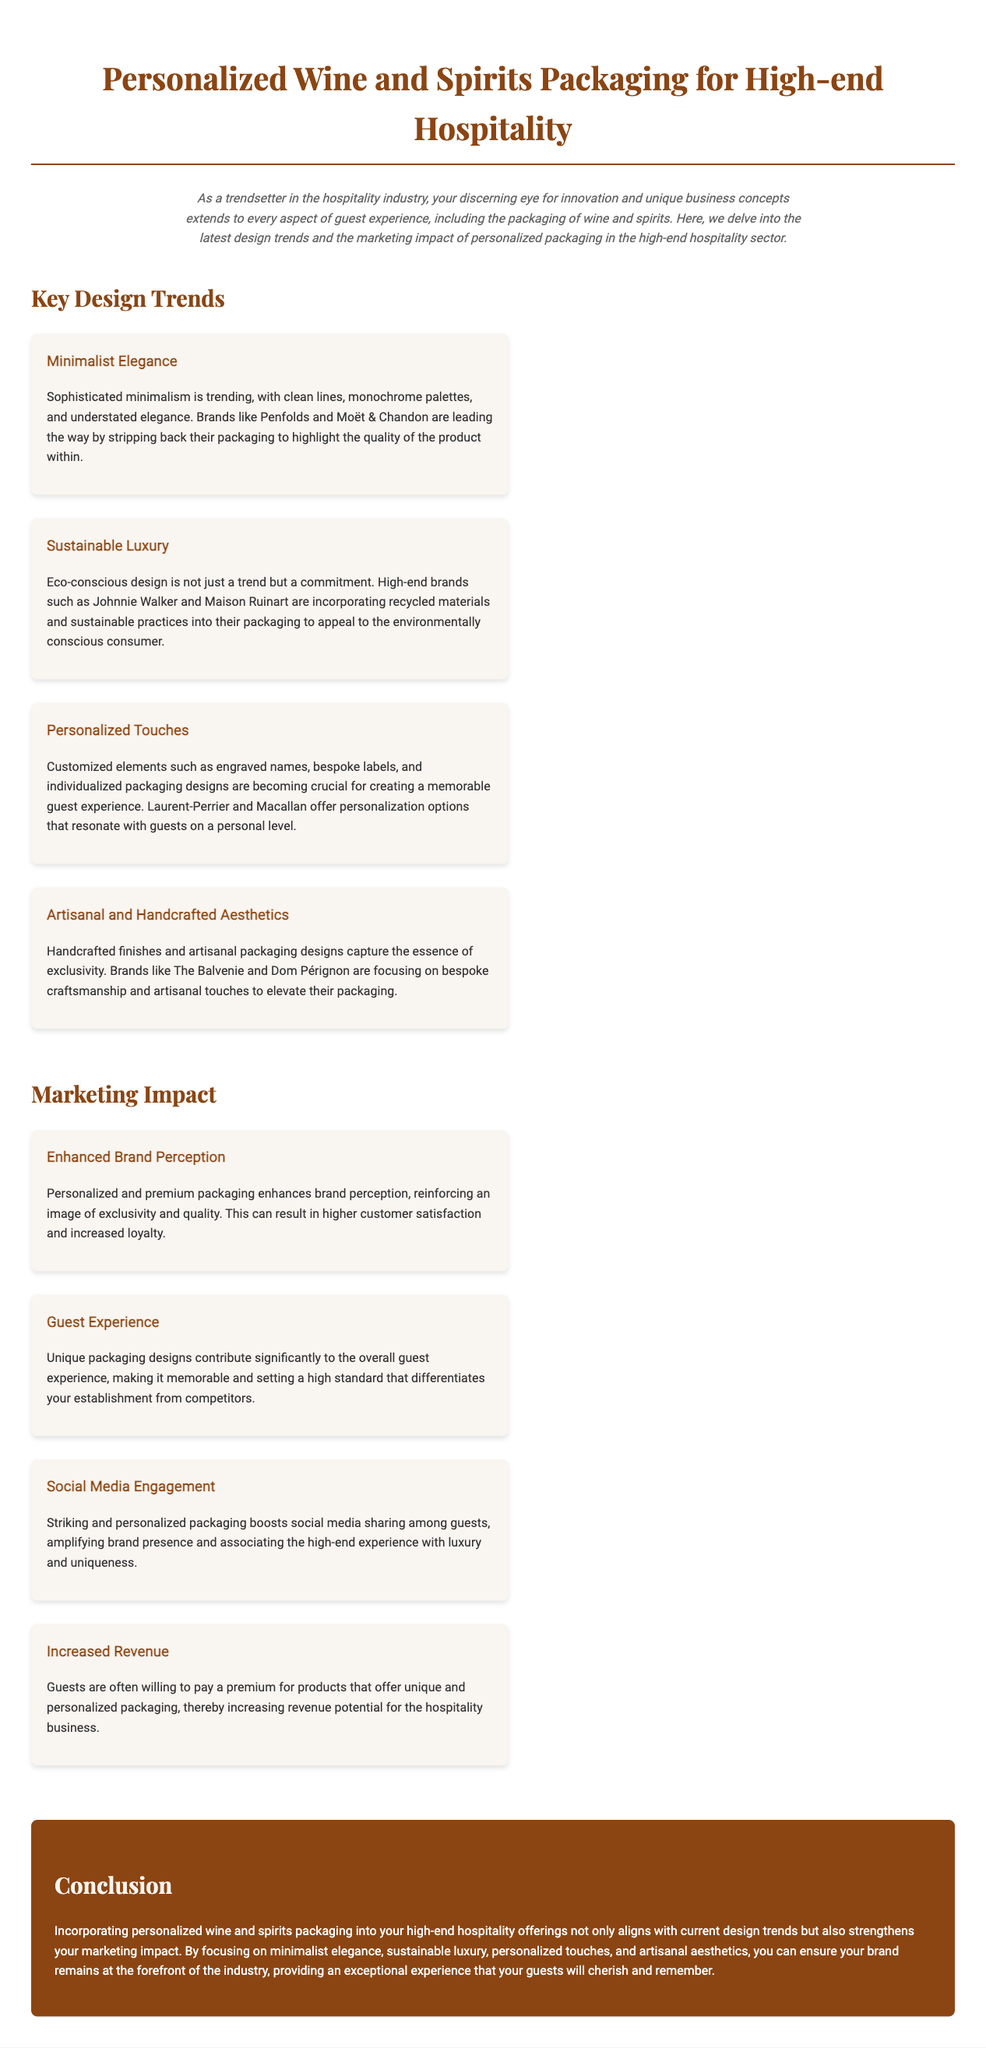What is the main topic of the document? The document discusses personalized wine and spirits packaging specifically for high-end hospitality settings.
Answer: Personalized Wine and Spirits Packaging Which brands are mentioned for minimalist elegance? The document specifically names Penfolds and Moët & Chandon as leading brands in minimalist elegance.
Answer: Penfolds, Moët & Chandon What trend emphasizes eco-conscious design? The document mentions "Sustainable Luxury" as the trend focused on eco-conscious design.
Answer: Sustainable Luxury How does personalized packaging affect brand perception? The document states that personalized packaging enhances brand perception and reinforces an image of exclusivity and quality.
Answer: Enhances brand perception What is a benefit of unique packaging designs? The document highlights that unique packaging designs contribute significantly to the overall guest experience.
Answer: Memorable guest experience Which two brands focus on artisanal packaging aesthetics? The document mentions The Balvenie and Dom Pérignon as brands focusing on artisanal packaging aesthetics.
Answer: The Balvenie, Dom Pérignon What impact does personalized packaging have on social media? The document indicates that striking and personalized packaging boosts social media sharing among guests.
Answer: Boosts social media sharing What is one way personalized packaging can increase revenue? The document explains that guests are often willing to pay a premium for unique and personalized packaging.
Answer: Guests pay a premium 